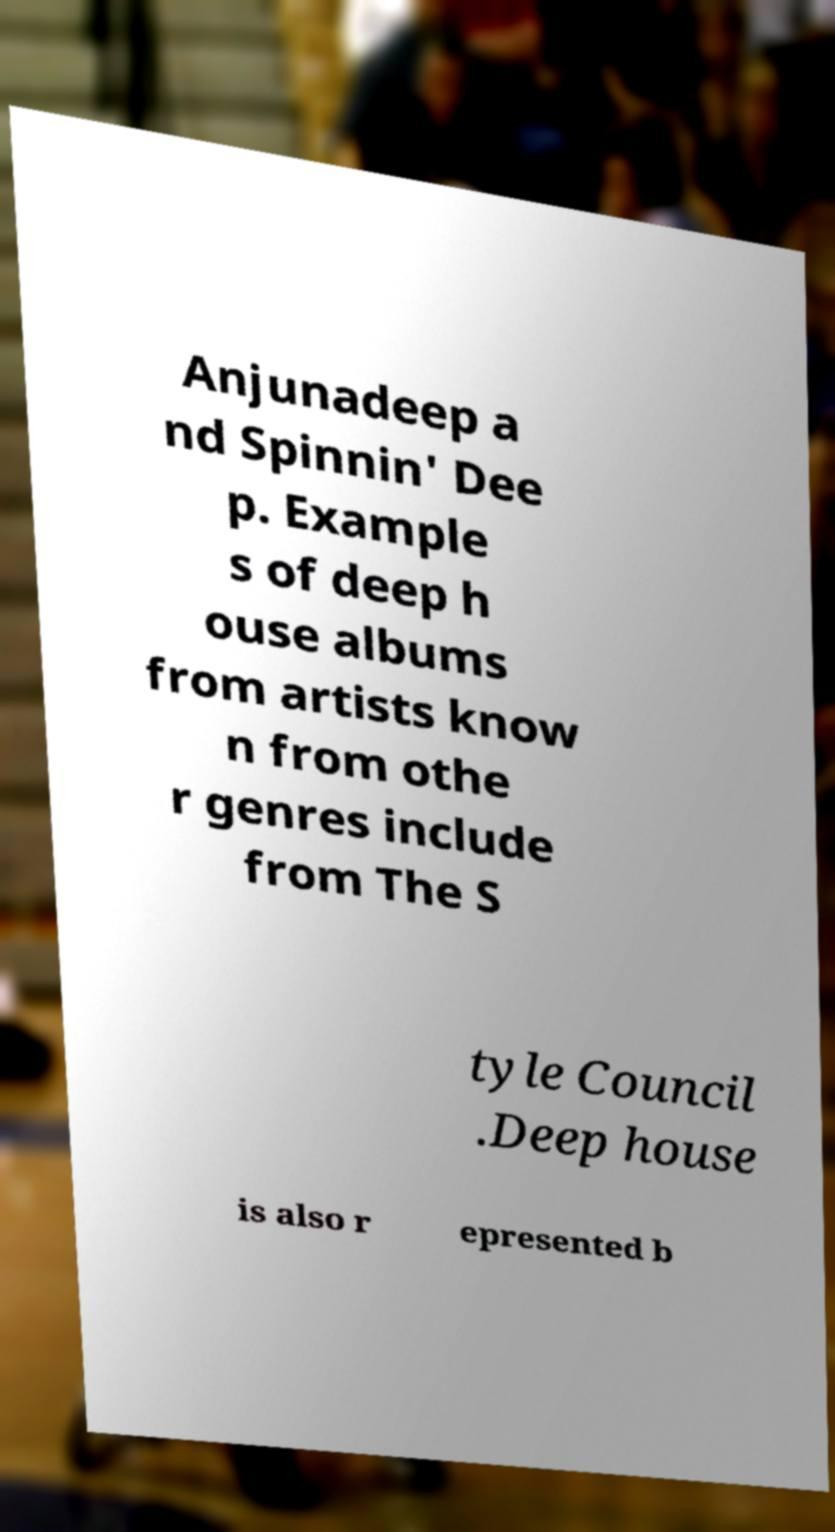Could you assist in decoding the text presented in this image and type it out clearly? Anjunadeep a nd Spinnin' Dee p. Example s of deep h ouse albums from artists know n from othe r genres include from The S tyle Council .Deep house is also r epresented b 